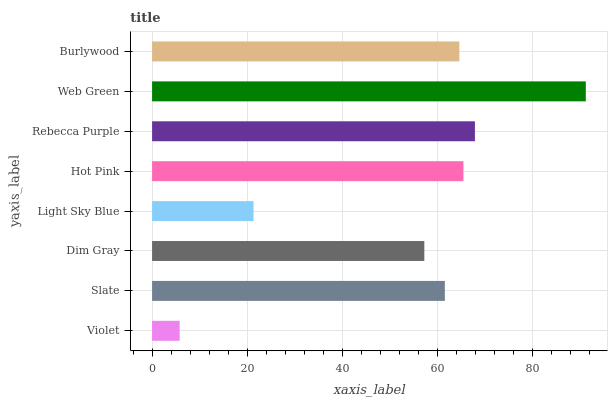Is Violet the minimum?
Answer yes or no. Yes. Is Web Green the maximum?
Answer yes or no. Yes. Is Slate the minimum?
Answer yes or no. No. Is Slate the maximum?
Answer yes or no. No. Is Slate greater than Violet?
Answer yes or no. Yes. Is Violet less than Slate?
Answer yes or no. Yes. Is Violet greater than Slate?
Answer yes or no. No. Is Slate less than Violet?
Answer yes or no. No. Is Burlywood the high median?
Answer yes or no. Yes. Is Slate the low median?
Answer yes or no. Yes. Is Web Green the high median?
Answer yes or no. No. Is Rebecca Purple the low median?
Answer yes or no. No. 